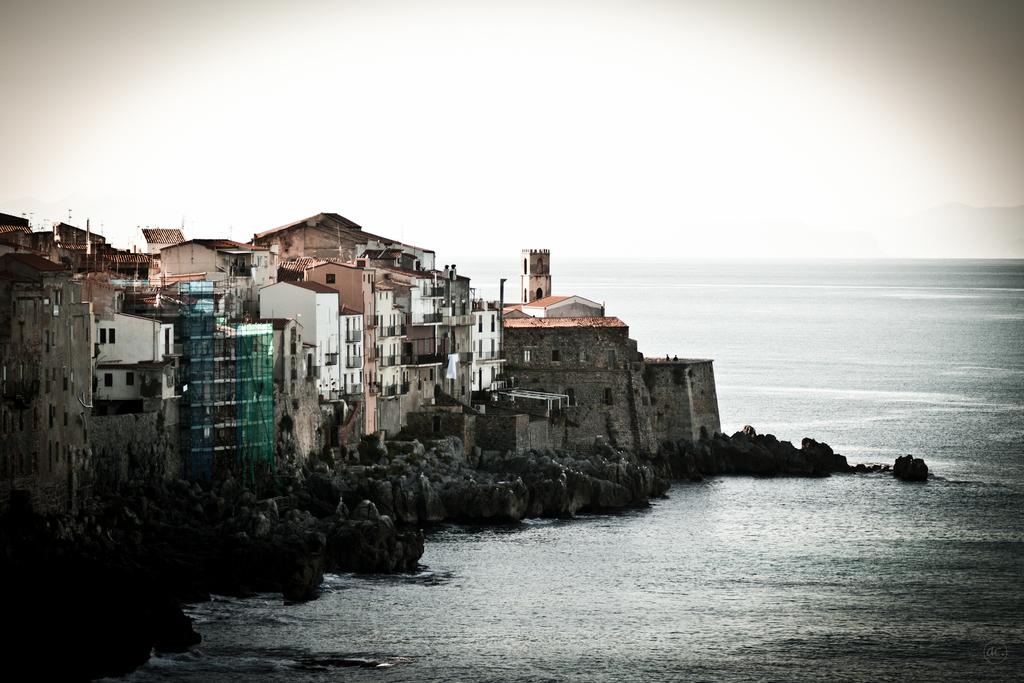What structures are located on the left side of the image? There are buildings on the left side of the image. What natural element is visible in the image? There is water visible in the image. What is the condition of the sky in the image? The sky is cloudy in the image. What type of screw can be seen holding the nation together in the image? There is no screw or nation present in the image; it features buildings, water, and a cloudy sky. What flavor of mint is depicted in the image? There is no mint present in the image. 